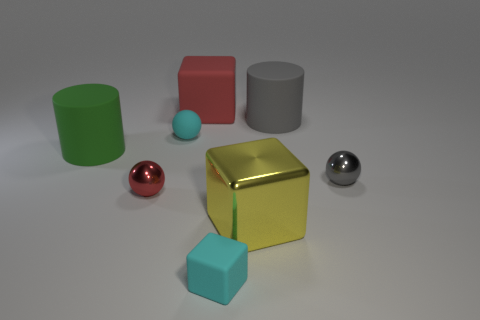Subtract all shiny balls. How many balls are left? 1 Subtract all gray spheres. How many spheres are left? 2 Subtract all tiny blocks. Subtract all cyan blocks. How many objects are left? 6 Add 1 balls. How many balls are left? 4 Add 3 big yellow shiny objects. How many big yellow shiny objects exist? 4 Add 1 tiny cyan rubber objects. How many objects exist? 9 Subtract 1 green cylinders. How many objects are left? 7 Subtract all cylinders. How many objects are left? 6 Subtract 2 blocks. How many blocks are left? 1 Subtract all purple cylinders. Subtract all purple spheres. How many cylinders are left? 2 